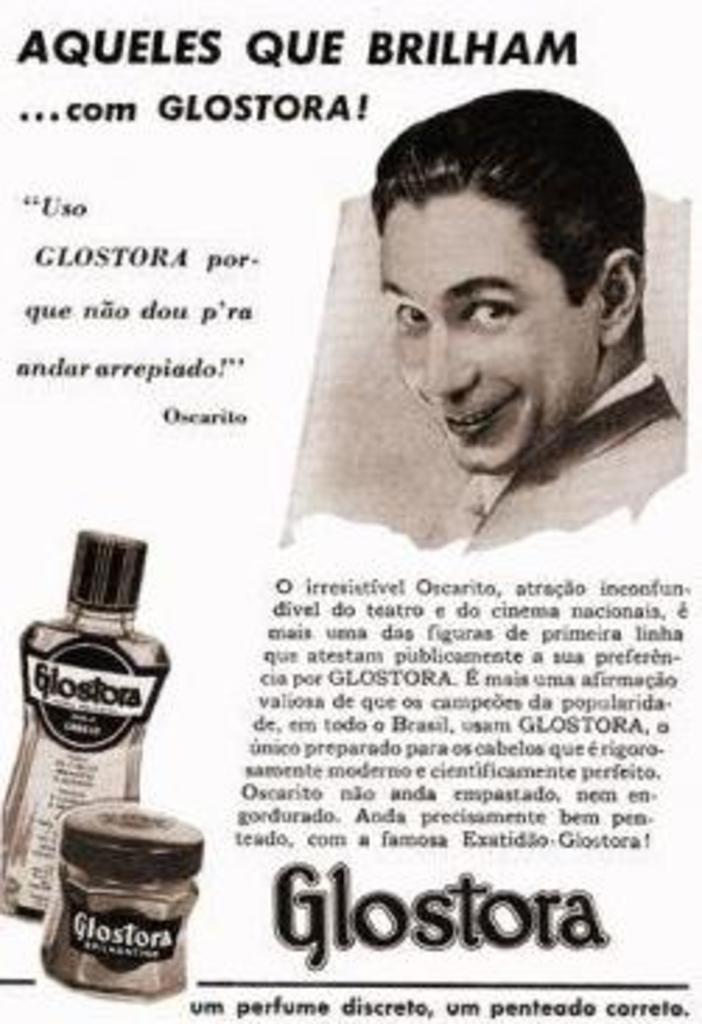<image>
Summarize the visual content of the image. a paper that has the word Glostora at the bottom 